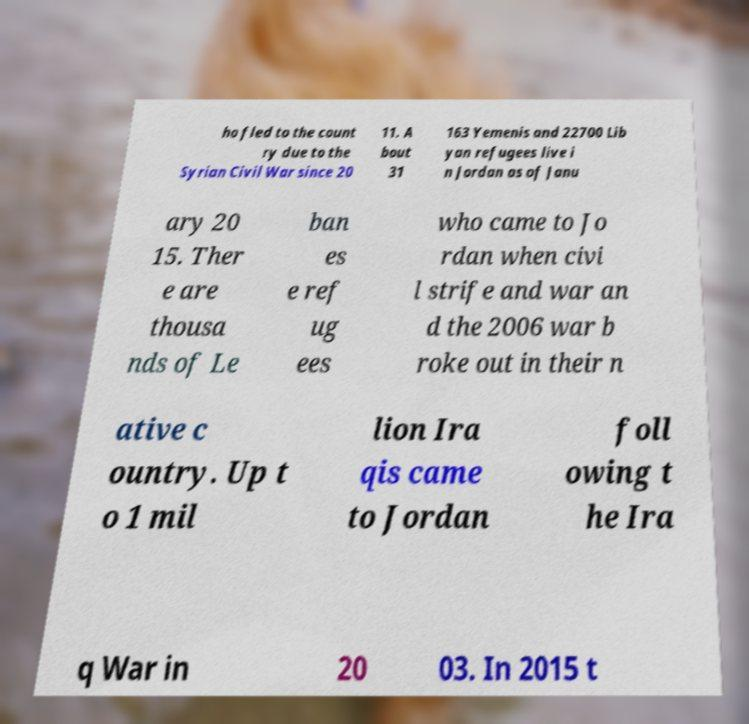For documentation purposes, I need the text within this image transcribed. Could you provide that? ho fled to the count ry due to the Syrian Civil War since 20 11. A bout 31 163 Yemenis and 22700 Lib yan refugees live i n Jordan as of Janu ary 20 15. Ther e are thousa nds of Le ban es e ref ug ees who came to Jo rdan when civi l strife and war an d the 2006 war b roke out in their n ative c ountry. Up t o 1 mil lion Ira qis came to Jordan foll owing t he Ira q War in 20 03. In 2015 t 